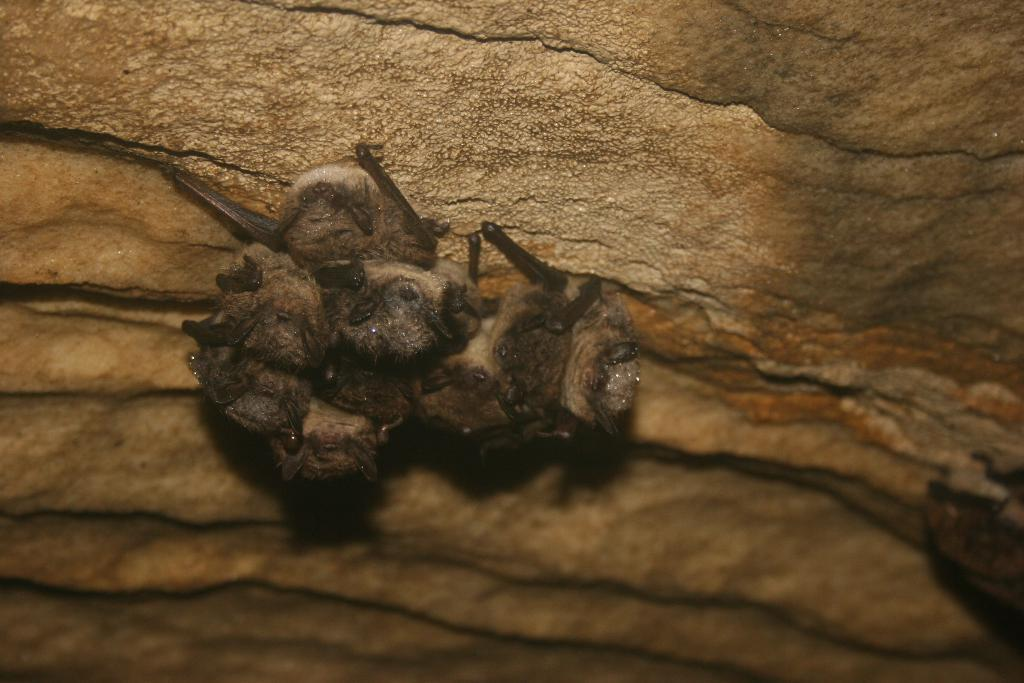How many moles are present in the image? There are four moles in the image. What can be found between the moles? There is bacteria between the moles. How many police officers are patrolling the area in the image? There are no police officers present in the image; it only features four moles and bacteria between them. What type of base is visible in the image? There is no base present in the image; it only features four moles and bacteria between them. 